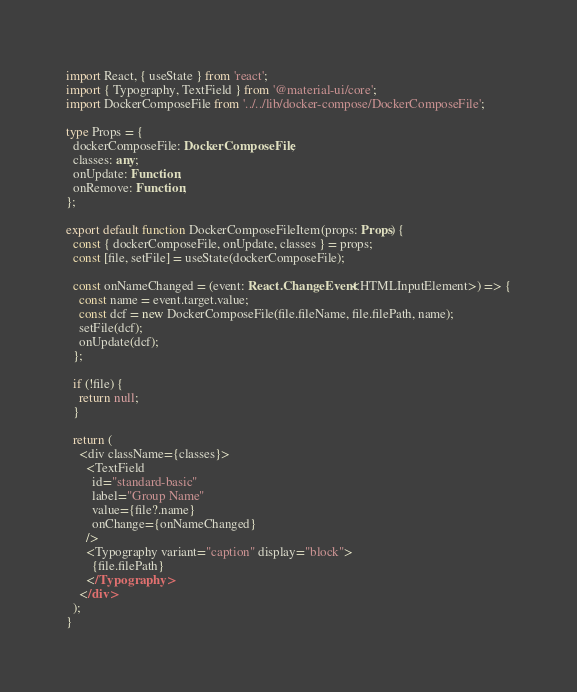<code> <loc_0><loc_0><loc_500><loc_500><_TypeScript_>import React, { useState } from 'react';
import { Typography, TextField } from '@material-ui/core';
import DockerComposeFile from '../../lib/docker-compose/DockerComposeFile';

type Props = {
  dockerComposeFile: DockerComposeFile;
  classes: any;
  onUpdate: Function;
  onRemove: Function;
};

export default function DockerComposeFileItem(props: Props) {
  const { dockerComposeFile, onUpdate, classes } = props;
  const [file, setFile] = useState(dockerComposeFile);

  const onNameChanged = (event: React.ChangeEvent<HTMLInputElement>) => {
    const name = event.target.value;
    const dcf = new DockerComposeFile(file.fileName, file.filePath, name);
    setFile(dcf);
    onUpdate(dcf);
  };

  if (!file) {
    return null;
  }

  return (
    <div className={classes}>
      <TextField
        id="standard-basic"
        label="Group Name"
        value={file?.name}
        onChange={onNameChanged}
      />
      <Typography variant="caption" display="block">
        {file.filePath}
      </Typography>
    </div>
  );
}
</code> 